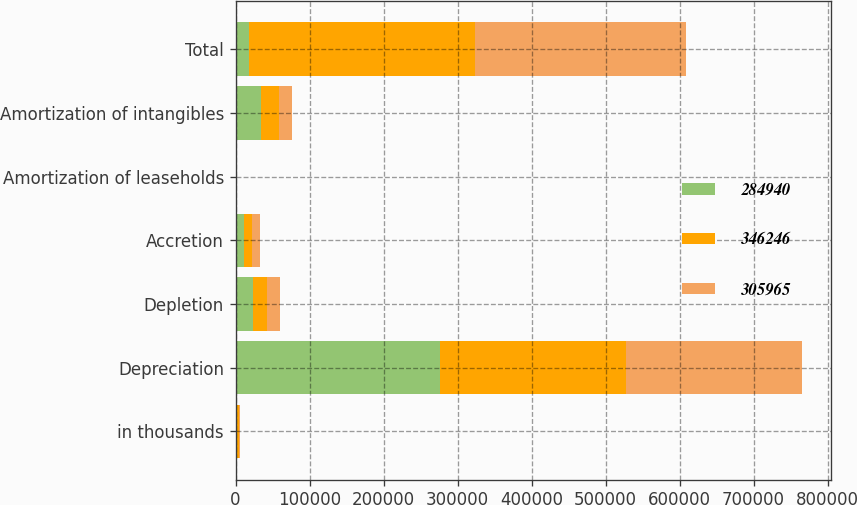Convert chart. <chart><loc_0><loc_0><loc_500><loc_500><stacked_bar_chart><ecel><fcel>in thousands<fcel>Depreciation<fcel>Depletion<fcel>Accretion<fcel>Amortization of leaseholds<fcel>Amortization of intangibles<fcel>Total<nl><fcel>284940<fcel>2018<fcel>276814<fcel>23260<fcel>10776<fcel>472<fcel>34924<fcel>17688.5<nl><fcel>346246<fcel>2017<fcel>250835<fcel>19342<fcel>11415<fcel>608<fcel>23765<fcel>305965<nl><fcel>305965<fcel>2016<fcel>238237<fcel>17812<fcel>11059<fcel>267<fcel>17565<fcel>284940<nl></chart> 